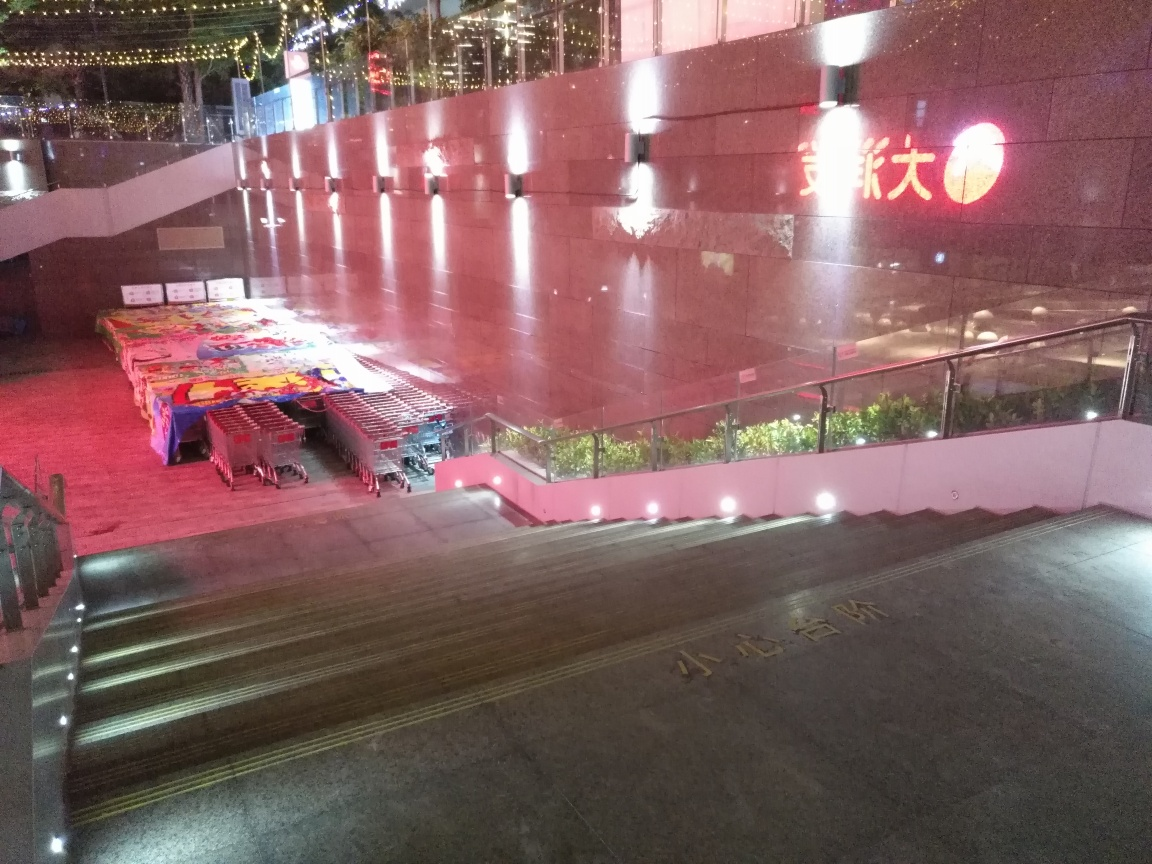Can you describe the atmosphere or mood that this picture conveys? The image conveys a quiet and calm atmosphere, accentuated by the warm lighting and the absence of active human presence. The stillness of the empty carts and clear pathways may evoke a sense of solitude or anticipation for the next day's activities. 